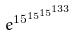Convert formula to latex. <formula><loc_0><loc_0><loc_500><loc_500>e ^ { 1 5 ^ { 1 5 ^ { 1 5 ^ { 1 3 3 } } } }</formula> 